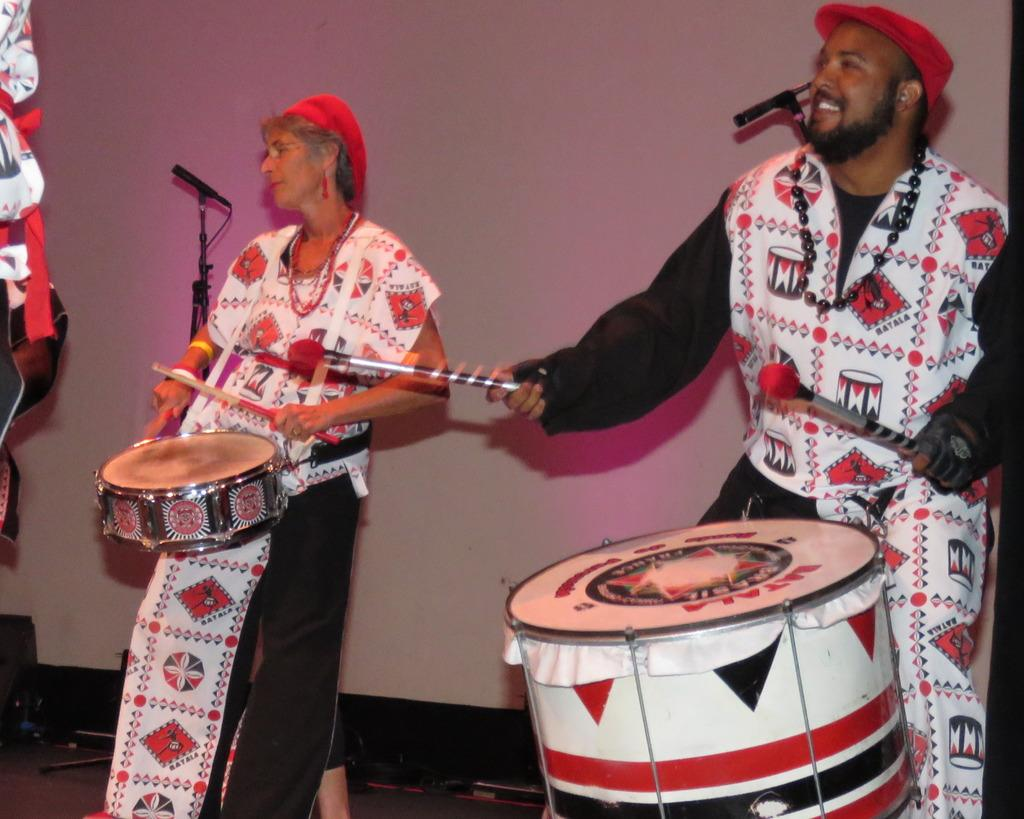How many people are in the image? There are two people standing in the center of the image. What are the two people doing? The two people are beating drums. What can be seen in the background of the image? There is a stand and a wall in the background of the image. What invention did the mom and brothers create together in the image? There is no mention of a mom or brothers in the image, and no invention is depicted. 